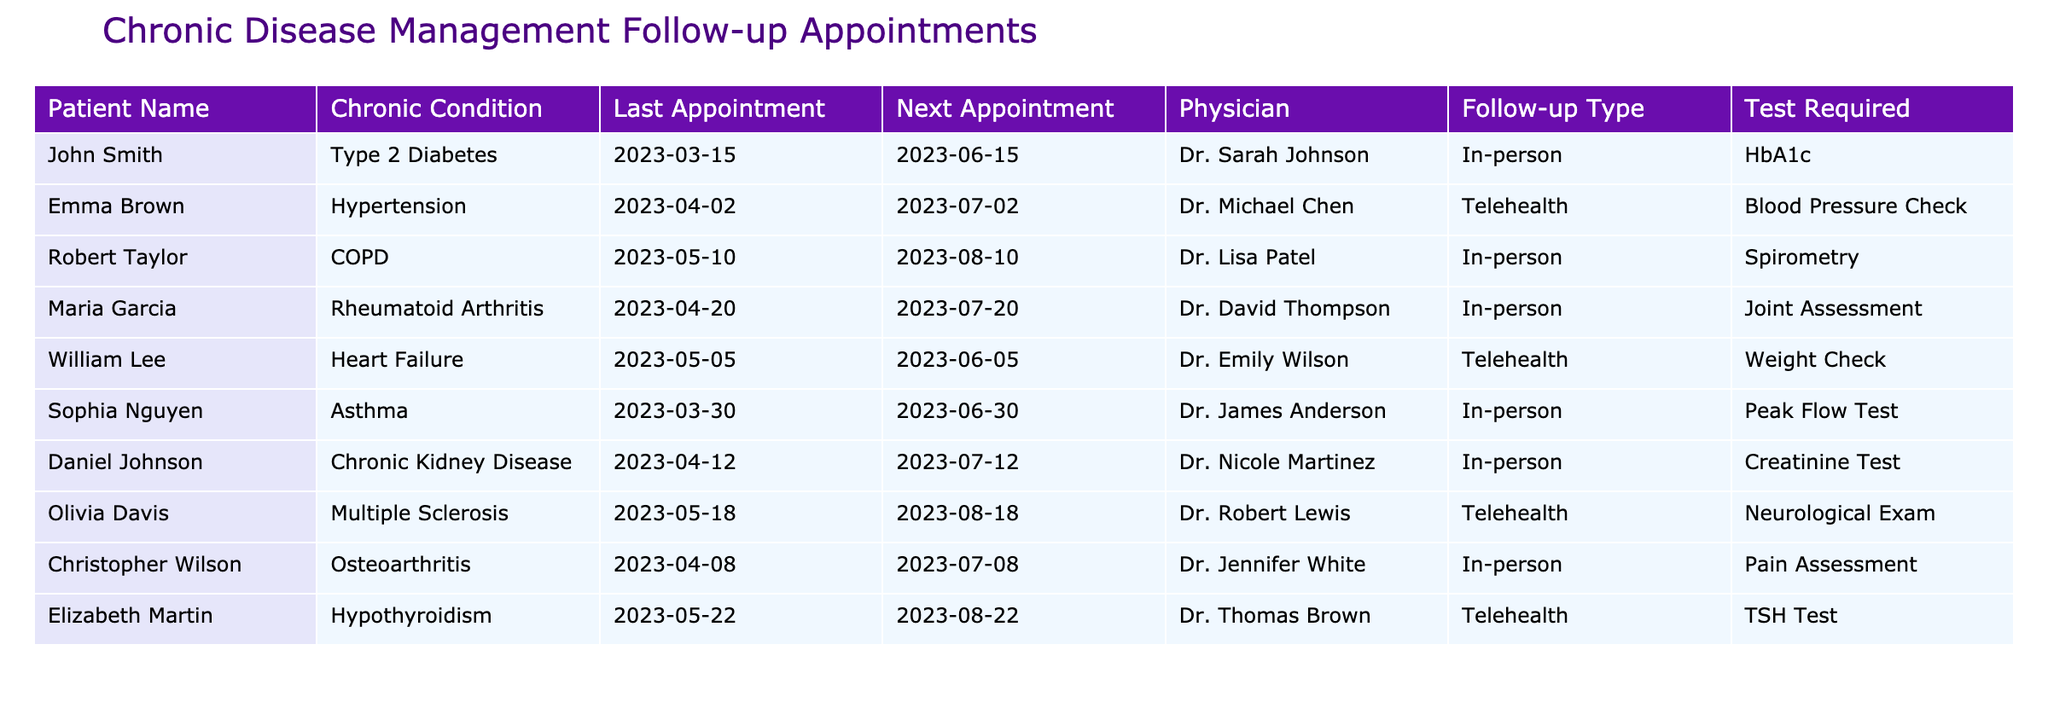What is the next appointment date for John Smith? The table lists John Smith's next appointment date in the "Next Appointment" column, which is provided directly under his row. The date is 2023-06-15.
Answer: 2023-06-15 Which patients have a follow-up type of telehealth? To answer this, I need to look at the "Follow-up Type" column and identify patients whose follow-up type is listed as "Telehealth." The patients are Emma Brown, William Lee, Olivia Davis, and Elizabeth Martin.
Answer: Emma Brown, William Lee, Olivia Davis, Elizabeth Martin What is the difference in days between John Smith's last appointment and his next appointment? John Smith's last appointment was on 2023-03-15 and the next one is on 2023-06-15. The difference can be calculated by finding the number of days between these two dates. The result is 92 days.
Answer: 92 Is there a patient with Chronic Kidney Disease scheduled for a follow-up appointment on the same date as Robert Taylor's next appointment? Robert Taylor's next appointment is scheduled for 2023-08-10. Looking at the "Next Appointment" column for other patients, I find that Daniel Johnson also has a next appointment on 2023-07-12. Therefore, no patient with Chronic Kidney Disease has an appointment on the same date as Robert's.
Answer: No Which chronic condition has the highest number of patients scheduled for in-person follow-up appointments? To find this, I analyze the "Chronic Condition" and filter by the "Follow-up Type" being "In-person." By reviewing the list, I see that there are 6 patients with different chronic conditions but the majority, which is 4, are chronic conditions seen in the in-person appointments. The conditions are Type 2 Diabetes, COPD, Rheumatoid Arthritis, and Asthma.
Answer: 4 patients with in-person appointments How many patients are scheduled for a weight check? I will check the "Test Required" column for the type of test that matches "Weight Check." From the table, I find that only William Lee is assigned a weight check.
Answer: 1 patient What is the average time between last appointments and next appointments for all patients? To calculate the average time between appointments, I need to find the difference in days for each patient's last and next appointment date, sum those differences, and divide by the number of patients. The total sum of differences is 546 days for 9 patients, leading to an average of 546/9 = 60.67 days.
Answer: Approximately 60.67 days Is Sophia Nguyen’s next appointment after Emma Brown’s next appointment? Checking the next appointment dates, Sophia Nguyen's next appointment is on 2023-06-30 and Emma Brown's is on 2023-07-02. Thus, Sophia's appointment is before Emma's.
Answer: No 